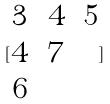Convert formula to latex. <formula><loc_0><loc_0><loc_500><loc_500>[ \begin{matrix} 3 & 4 & 5 \\ 4 & 7 \\ 6 \end{matrix} ]</formula> 